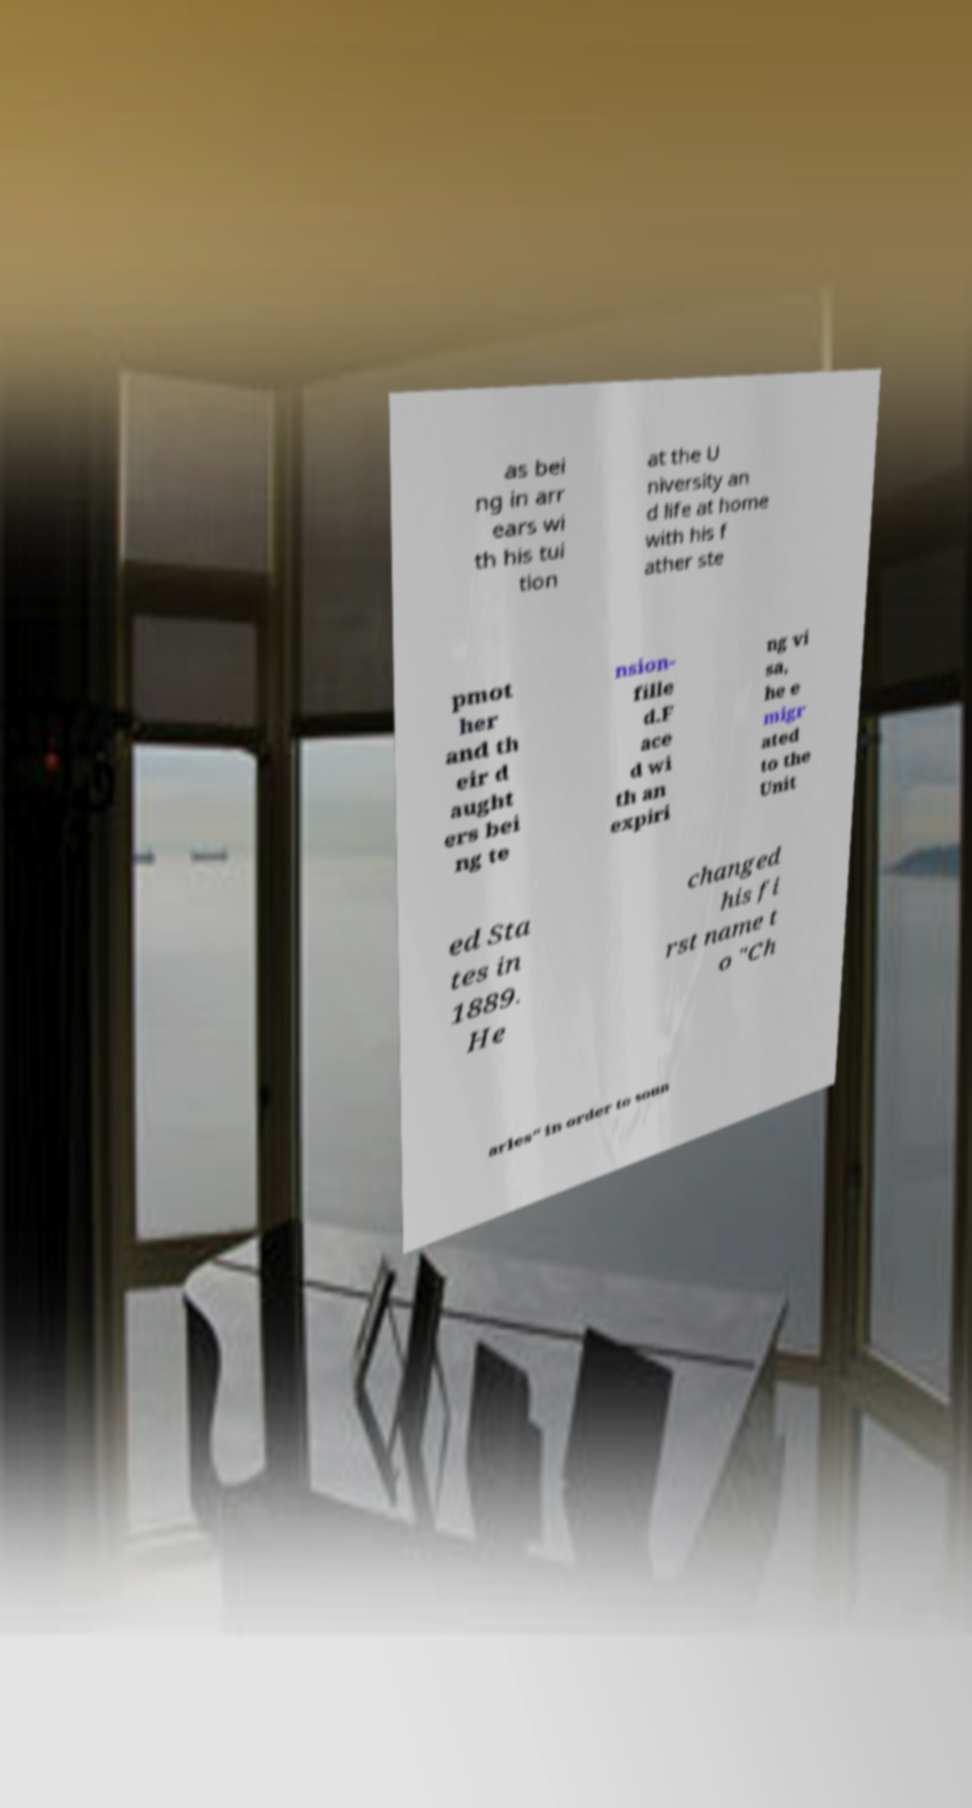Can you accurately transcribe the text from the provided image for me? as bei ng in arr ears wi th his tui tion at the U niversity an d life at home with his f ather ste pmot her and th eir d aught ers bei ng te nsion- fille d.F ace d wi th an expiri ng vi sa, he e migr ated to the Unit ed Sta tes in 1889. He changed his fi rst name t o "Ch arles" in order to soun 